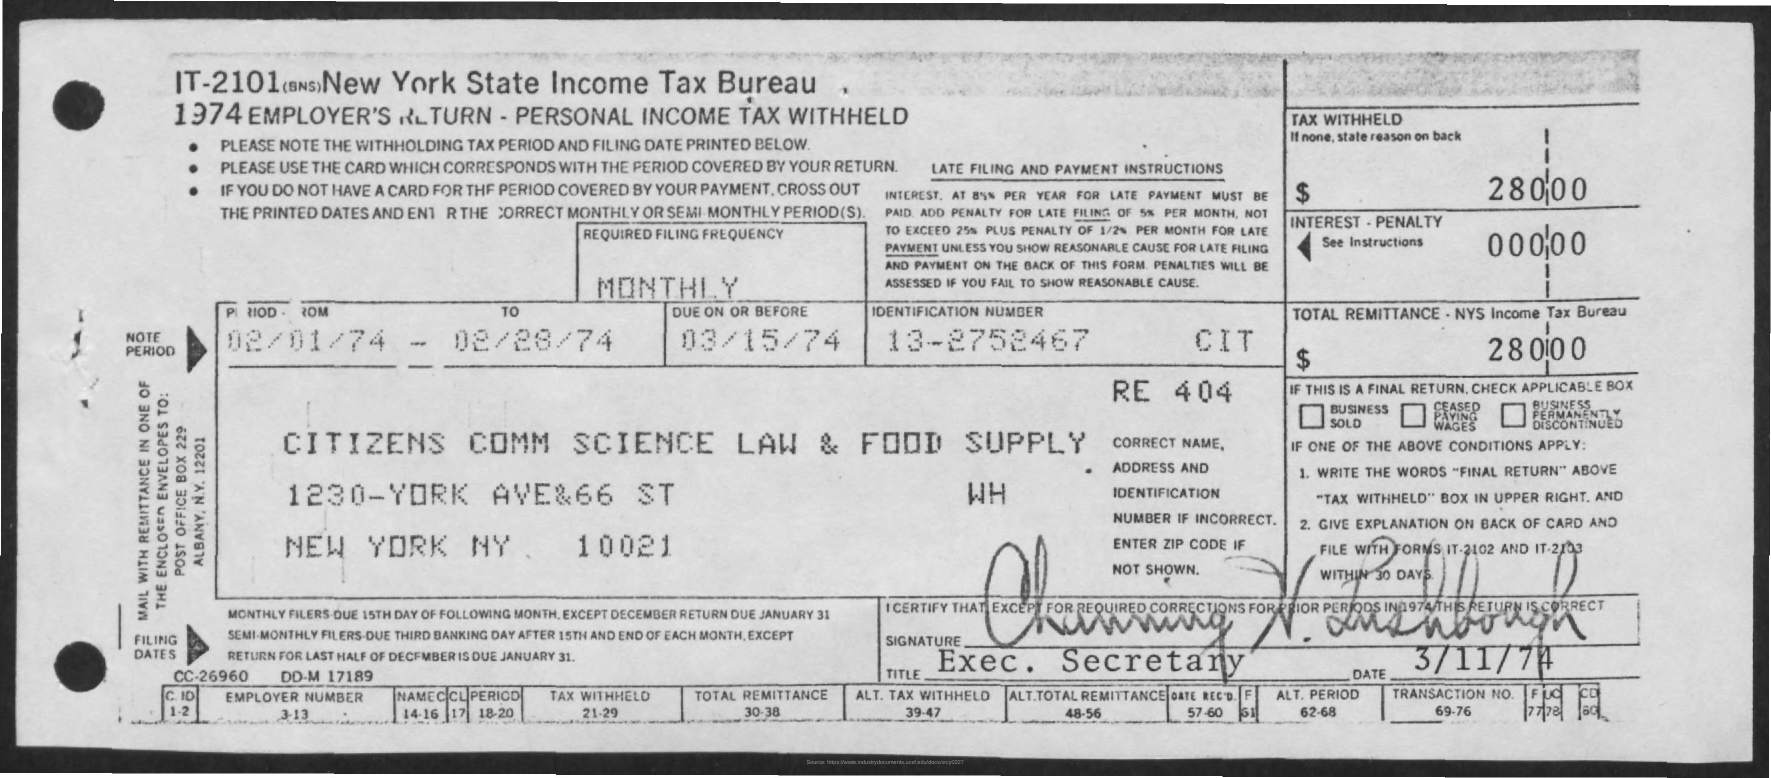How much is the Tax Withheld?
Keep it short and to the point. $ 280-00. What is the Interest - Penalty?
Give a very brief answer. 000-00. What is the Total Remittance?
Ensure brevity in your answer.  280.00. When is it Due on or before?
Your response must be concise. 03/15/74. What is the Identification Number?
Your response must be concise. 13-2752467. What is the Period(From)?
Offer a terse response. 02/01/74. What is the Period(To)?
Offer a very short reply. 02/28/74. 